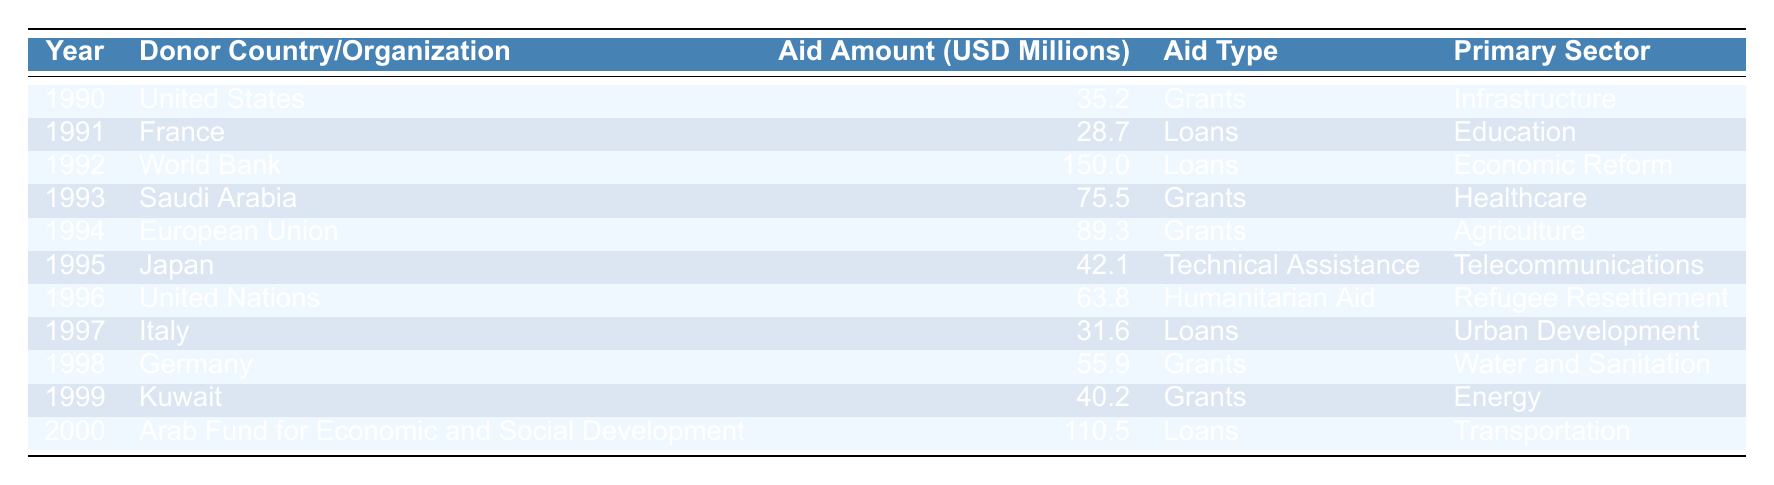What was the total aid amount received by Lebanon in 1992? According to the table, the aid amount received in 1992 is 150.0 million USD, provided by the World Bank.
Answer: 150.0 million USD Which donor provided the largest amount of aid during this period? From the table, the World Bank provided the largest aid amount of 150.0 million USD in 1992.
Answer: World Bank What type of aid did Kuwait provide in 1999? The table shows that Kuwait provided Grants as the type of aid in 1999.
Answer: Grants How much aid did the United States provide compared to Japan? The United States provided 35.2 million USD in 1990, while Japan provided 42.1 million USD in 1995. The difference is 42.1 - 35.2 = 6.9 million USD more from Japan.
Answer: Japan provided 6.9 million USD more What was the primary sector for the aid provided by the Arab Fund for Economic and Social Development? As noted in the table, the primary sector for the Arab Fund for Economic and Social Development in 2000 was Transportation.
Answer: Transportation Did Lebanon receive any humanitarian aid? The table indicates that the United Nations provided humanitarian aid in 1996.
Answer: Yes What was the average aid amount received each year from 1990 to 2000? To find the average, we sum the aid amounts: 35.2 + 28.7 + 150.0 + 75.5 + 89.3 + 42.1 + 63.8 + 31.6 + 55.9 + 40.2 + 110.5 =  682.8 million USD. There are 11 years, so the average is 682.8 / 11 ≈ 62.08 million USD.
Answer: Approximately 62.08 million USD Which year had the highest loan amount and what was it? The table states that the highest loan amount was from the World Bank in 1992, totaling 150.0 million USD.
Answer: 150.0 million USD in 1992 How many times did France provide aid during the years listed? France provided aid once in 1991, as noted in the table.
Answer: Once Was there any aid for Agriculture and if so, who provided it? Yes, according to the table, the European Union provided Grants for Agriculture in 1994.
Answer: Yes, European Union provided it 